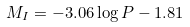<formula> <loc_0><loc_0><loc_500><loc_500>M _ { I } = - 3 . 0 6 \log P - 1 . 8 1</formula> 